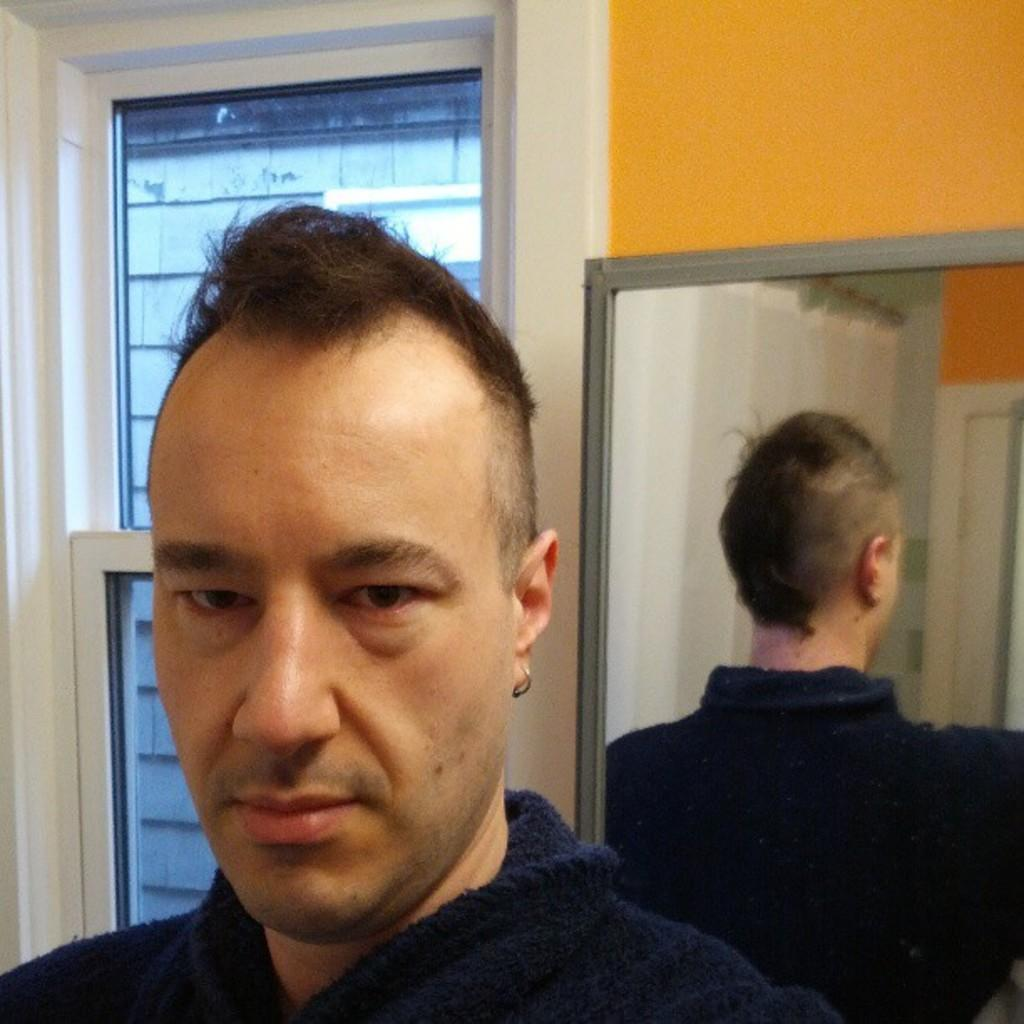What is the main subject in the image? There is a man standing in the image. What can be seen behind the man? There is a wall in the image. What is attached to the wall? There is a mirror on the wall. What is visible through the windows in the image? There are windows visible in the image. Can you see a van parked outside the windows in the image? There is no van visible through the windows in the image. Is there a pear on the wall next to the mirror? There is no pear present in the image. 